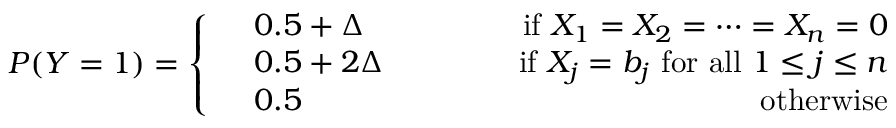Convert formula to latex. <formula><loc_0><loc_0><loc_500><loc_500>\begin{array} { r } { P ( Y = 1 ) = \left \{ \begin{array} { r l r } & { 0 . 5 + \Delta \quad } & { i f \ X _ { 1 } = X _ { 2 } = \cdots = X _ { n } = 0 } \\ & { 0 . 5 + 2 \Delta \quad } & { i f \ X _ { j } = b _ { j } \ f o r a l l \ 1 \leq j \leq n } \\ & { 0 . 5 } & { o t h e r w i s e } \end{array} } \end{array}</formula> 